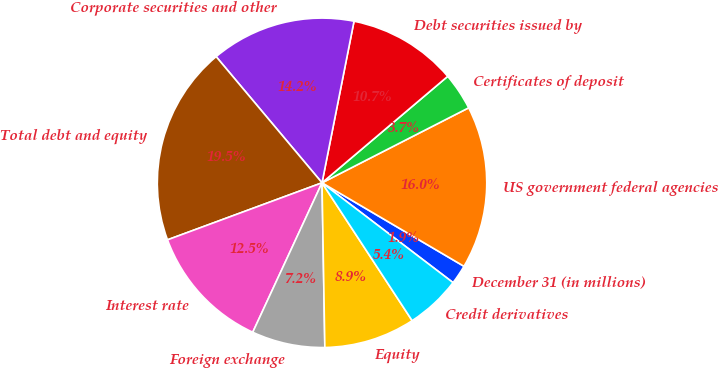Convert chart. <chart><loc_0><loc_0><loc_500><loc_500><pie_chart><fcel>December 31 (in millions)<fcel>US government federal agencies<fcel>Certificates of deposit<fcel>Debt securities issued by<fcel>Corporate securities and other<fcel>Total debt and equity<fcel>Interest rate<fcel>Foreign exchange<fcel>Equity<fcel>Credit derivatives<nl><fcel>1.9%<fcel>15.98%<fcel>3.66%<fcel>10.7%<fcel>14.22%<fcel>19.51%<fcel>12.46%<fcel>7.18%<fcel>8.94%<fcel>5.42%<nl></chart> 